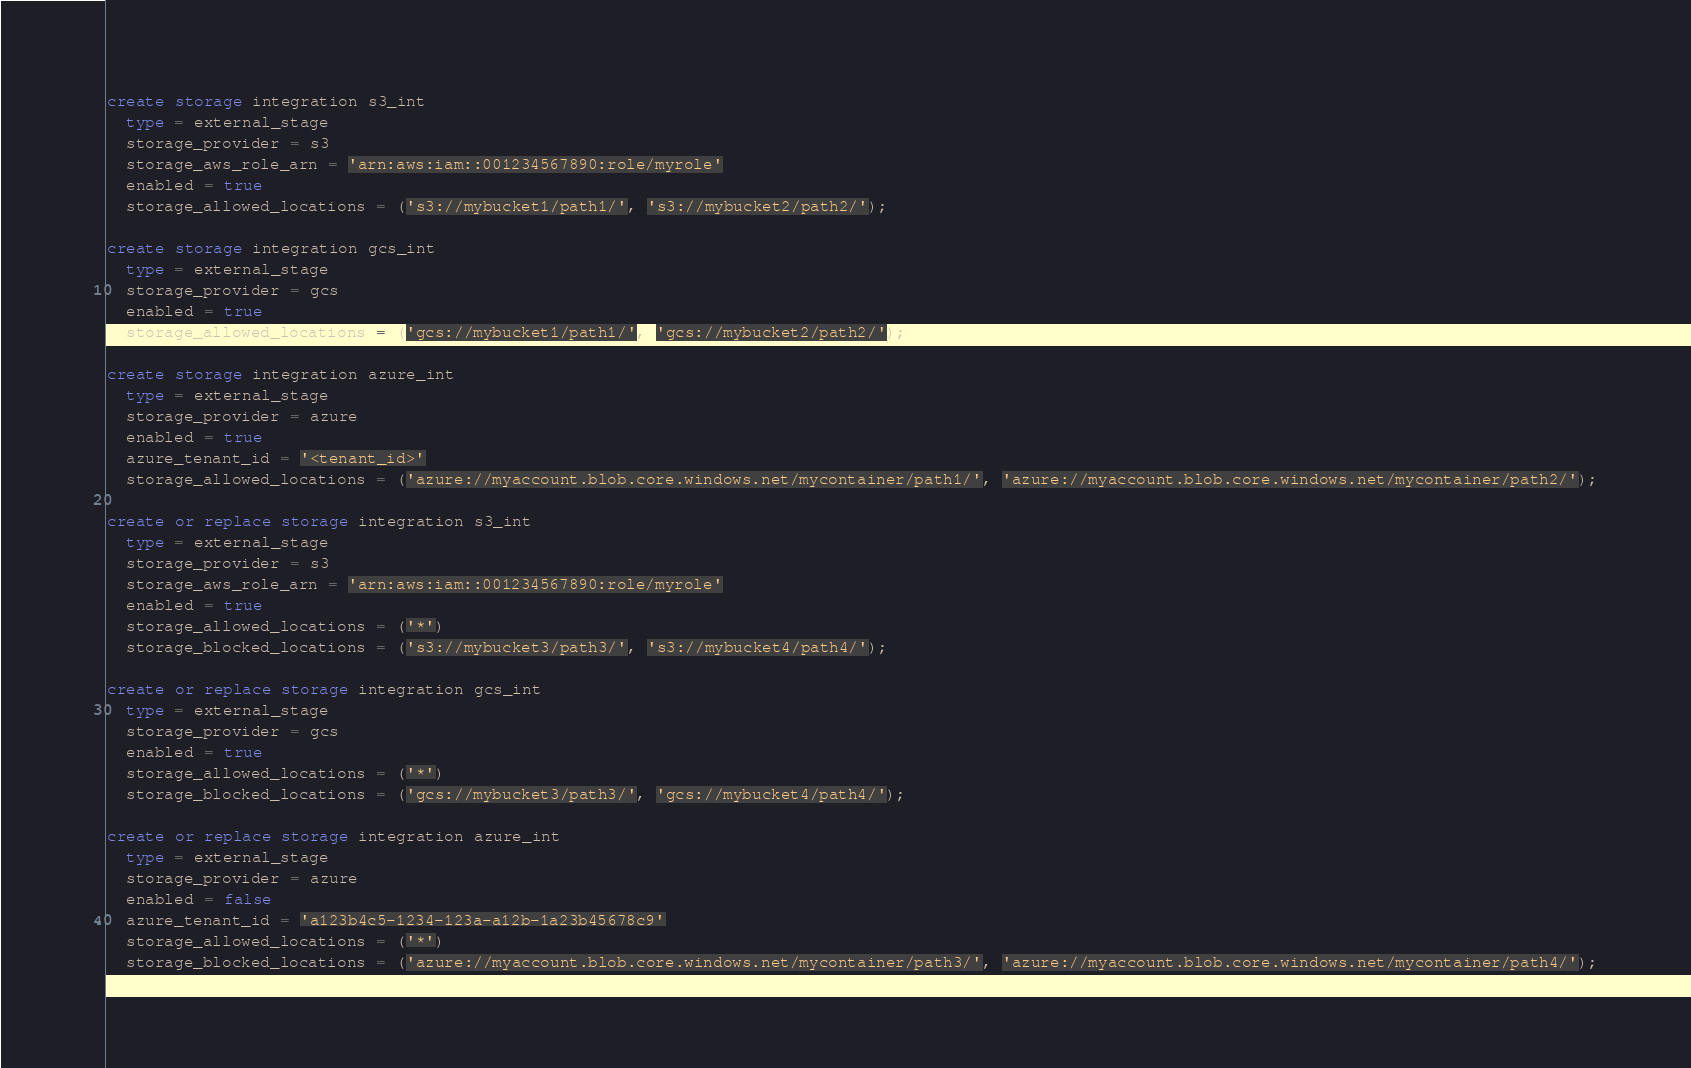Convert code to text. <code><loc_0><loc_0><loc_500><loc_500><_SQL_>create storage integration s3_int
  type = external_stage
  storage_provider = s3
  storage_aws_role_arn = 'arn:aws:iam::001234567890:role/myrole'
  enabled = true
  storage_allowed_locations = ('s3://mybucket1/path1/', 's3://mybucket2/path2/');

create storage integration gcs_int
  type = external_stage
  storage_provider = gcs
  enabled = true
  storage_allowed_locations = ('gcs://mybucket1/path1/', 'gcs://mybucket2/path2/');

create storage integration azure_int
  type = external_stage
  storage_provider = azure
  enabled = true
  azure_tenant_id = '<tenant_id>'
  storage_allowed_locations = ('azure://myaccount.blob.core.windows.net/mycontainer/path1/', 'azure://myaccount.blob.core.windows.net/mycontainer/path2/');

create or replace storage integration s3_int
  type = external_stage
  storage_provider = s3
  storage_aws_role_arn = 'arn:aws:iam::001234567890:role/myrole'
  enabled = true
  storage_allowed_locations = ('*')
  storage_blocked_locations = ('s3://mybucket3/path3/', 's3://mybucket4/path4/');

create or replace storage integration gcs_int
  type = external_stage
  storage_provider = gcs
  enabled = true
  storage_allowed_locations = ('*')
  storage_blocked_locations = ('gcs://mybucket3/path3/', 'gcs://mybucket4/path4/');

create or replace storage integration azure_int
  type = external_stage
  storage_provider = azure
  enabled = false
  azure_tenant_id = 'a123b4c5-1234-123a-a12b-1a23b45678c9'
  storage_allowed_locations = ('*')
  storage_blocked_locations = ('azure://myaccount.blob.core.windows.net/mycontainer/path3/', 'azure://myaccount.blob.core.windows.net/mycontainer/path4/');
</code> 